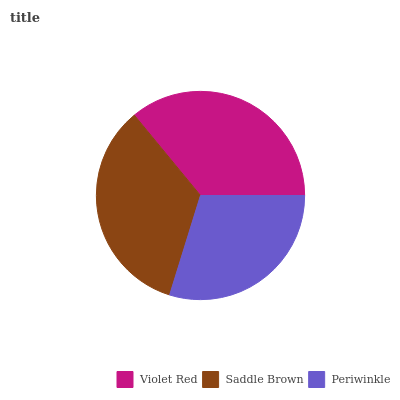Is Periwinkle the minimum?
Answer yes or no. Yes. Is Violet Red the maximum?
Answer yes or no. Yes. Is Saddle Brown the minimum?
Answer yes or no. No. Is Saddle Brown the maximum?
Answer yes or no. No. Is Violet Red greater than Saddle Brown?
Answer yes or no. Yes. Is Saddle Brown less than Violet Red?
Answer yes or no. Yes. Is Saddle Brown greater than Violet Red?
Answer yes or no. No. Is Violet Red less than Saddle Brown?
Answer yes or no. No. Is Saddle Brown the high median?
Answer yes or no. Yes. Is Saddle Brown the low median?
Answer yes or no. Yes. Is Violet Red the high median?
Answer yes or no. No. Is Violet Red the low median?
Answer yes or no. No. 